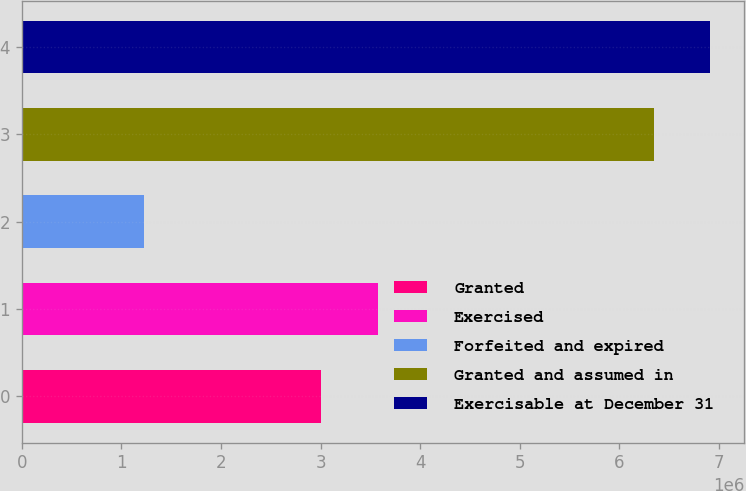<chart> <loc_0><loc_0><loc_500><loc_500><bar_chart><fcel>Granted<fcel>Exercised<fcel>Forfeited and expired<fcel>Granted and assumed in<fcel>Exercisable at December 31<nl><fcel>3.009e+06<fcel>3.5736e+06<fcel>1.23e+06<fcel>6.345e+06<fcel>6.9096e+06<nl></chart> 